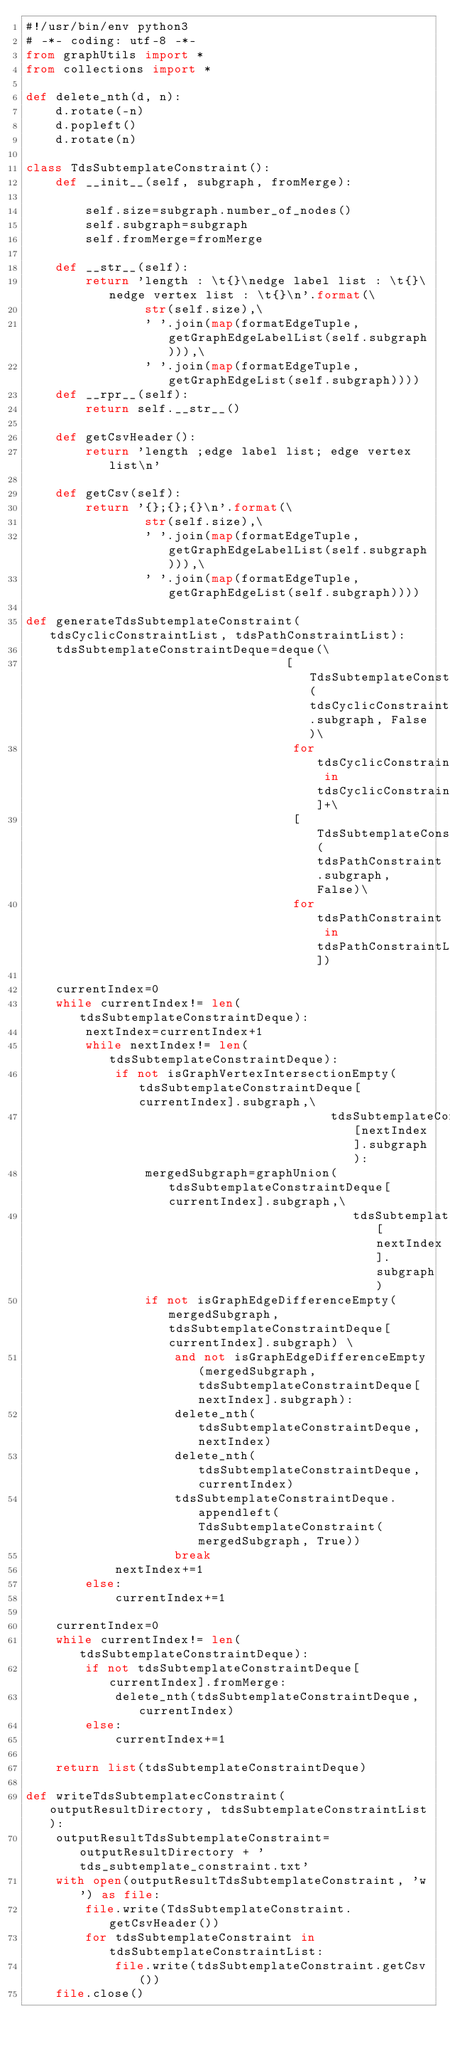Convert code to text. <code><loc_0><loc_0><loc_500><loc_500><_Python_>#!/usr/bin/env python3
# -*- coding: utf-8 -*-
from graphUtils import *
from collections import *

def delete_nth(d, n):
    d.rotate(-n)
    d.popleft()
    d.rotate(n)

class TdsSubtemplateConstraint():
    def __init__(self, subgraph, fromMerge):
        
        self.size=subgraph.number_of_nodes()
        self.subgraph=subgraph
        self.fromMerge=fromMerge
                
    def __str__(self):
        return 'length : \t{}\nedge label list : \t{}\nedge vertex list : \t{}\n'.format(\
                str(self.size),\
                ' '.join(map(formatEdgeTuple, getGraphEdgeLabelList(self.subgraph))),\
                ' '.join(map(formatEdgeTuple, getGraphEdgeList(self.subgraph))))
    def __rpr__(self):
        return self.__str__()
    
    def getCsvHeader():        
        return 'length ;edge label list; edge vertex list\n'
        
    def getCsv(self):
        return '{};{};{}\n'.format(\
                str(self.size),\
                ' '.join(map(formatEdgeTuple, getGraphEdgeLabelList(self.subgraph))),\
                ' '.join(map(formatEdgeTuple, getGraphEdgeList(self.subgraph))))

def generateTdsSubtemplateConstraint(tdsCyclicConstraintList, tdsPathConstraintList):
    tdsSubtemplateConstraintDeque=deque(\
                                   [TdsSubtemplateConstraint(tdsCyclicConstraint.subgraph, False)\
                                    for tdsCyclicConstraint in tdsCyclicConstraintList]+\
                                    [TdsSubtemplateConstraint(tdsPathConstraint.subgraph, False)\
                                    for tdsPathConstraint in tdsPathConstraintList])
    
    currentIndex=0
    while currentIndex!= len(tdsSubtemplateConstraintDeque):
        nextIndex=currentIndex+1
        while nextIndex!= len(tdsSubtemplateConstraintDeque):
            if not isGraphVertexIntersectionEmpty(tdsSubtemplateConstraintDeque[currentIndex].subgraph,\
                                         tdsSubtemplateConstraintDeque[nextIndex].subgraph):
                mergedSubgraph=graphUnion(tdsSubtemplateConstraintDeque[currentIndex].subgraph,\
                                            tdsSubtemplateConstraintDeque[nextIndex].subgraph)
                if not isGraphEdgeDifferenceEmpty(mergedSubgraph,tdsSubtemplateConstraintDeque[currentIndex].subgraph) \
                    and not isGraphEdgeDifferenceEmpty(mergedSubgraph,tdsSubtemplateConstraintDeque[nextIndex].subgraph):
                    delete_nth(tdsSubtemplateConstraintDeque, nextIndex)
                    delete_nth(tdsSubtemplateConstraintDeque, currentIndex)
                    tdsSubtemplateConstraintDeque.appendleft(TdsSubtemplateConstraint(mergedSubgraph, True))
                    break
            nextIndex+=1   
        else:
            currentIndex+=1
    
    currentIndex=0
    while currentIndex!= len(tdsSubtemplateConstraintDeque):
        if not tdsSubtemplateConstraintDeque[currentIndex].fromMerge:
            delete_nth(tdsSubtemplateConstraintDeque, currentIndex)            
        else:
            currentIndex+=1
    
    return list(tdsSubtemplateConstraintDeque)
    
def writeTdsSubtemplatecConstraint(outputResultDirectory, tdsSubtemplateConstraintList):
    outputResultTdsSubtemplateConstraint=outputResultDirectory + 'tds_subtemplate_constraint.txt'
    with open(outputResultTdsSubtemplateConstraint, 'w') as file:
        file.write(TdsSubtemplateConstraint.getCsvHeader())
        for tdsSubtemplateConstraint in tdsSubtemplateConstraintList:
            file.write(tdsSubtemplateConstraint.getCsv())
    file.close()   
</code> 